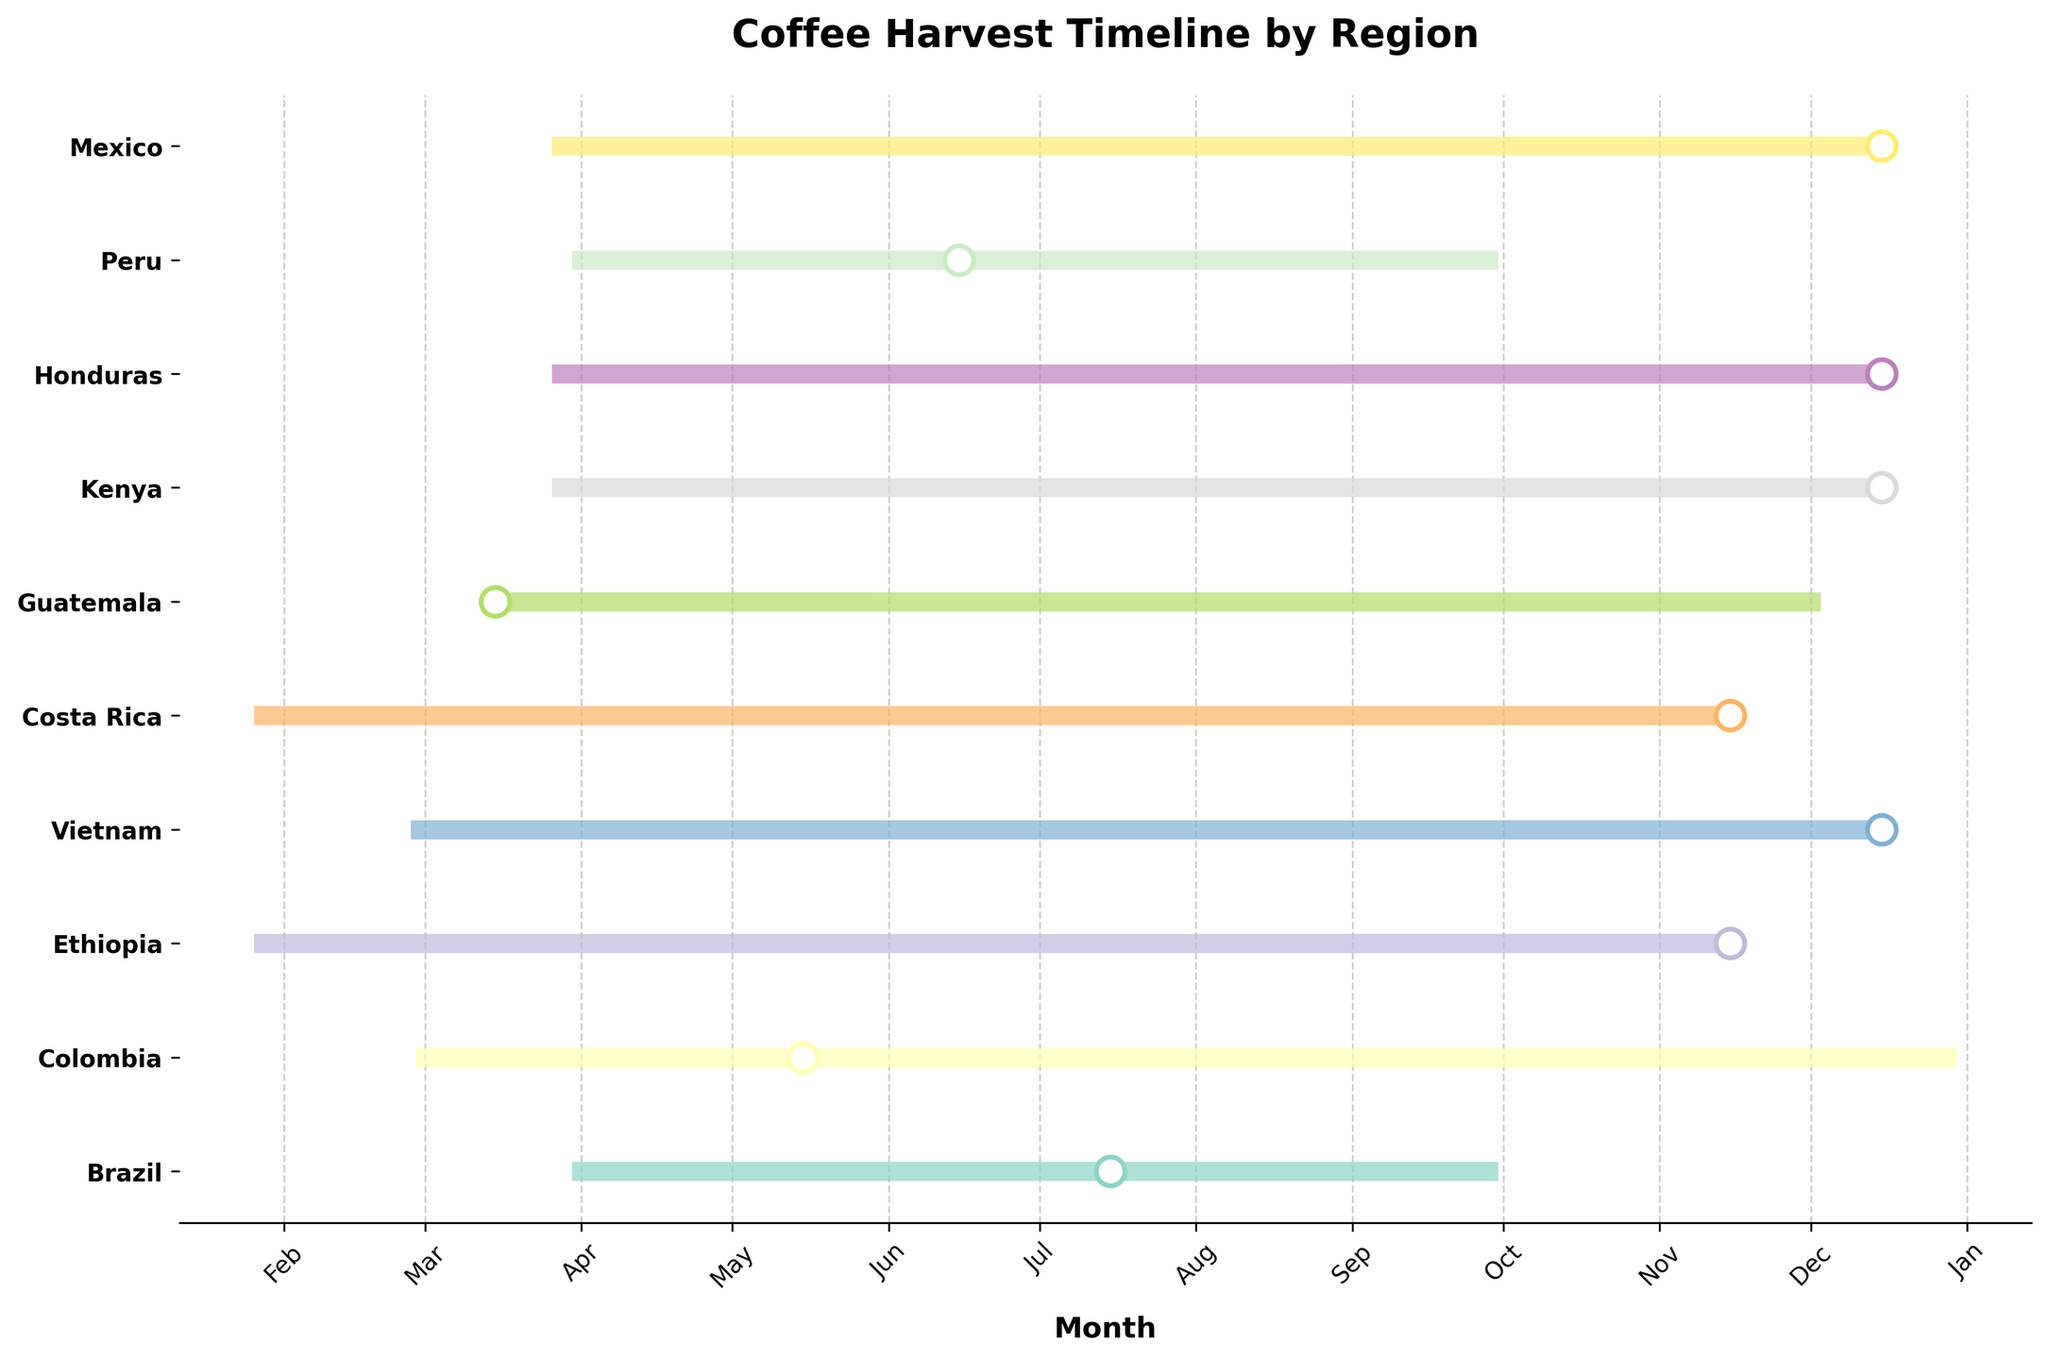What's the title of the plot? The title of the plot is typically positioned at the top of the figure, indicating the main subject or focus of the visualization.
Answer: Coffee Harvest Timeline by Region Which region has the earliest harvest start? To find the region with the earliest harvest start, look at the beginning points of each line on the timeline. The earliest harvest start date on the x-axis corresponds to March in Colombia.
Answer: Colombia During which months does Brazil's coffee harvest occur? Identify the range of the line corresponding to Brazil on the timeline. The line spans from April to September, which includes April, May, June, July, August, and September.
Answer: April to September Which regions have overlapping harvest peaks in December? Identify the regions with peak markers (the white circle) located in December. These regions include Vietnam, Kenya, Honduras, and Mexico.
Answer: Vietnam, Kenya, Honduras, Mexico What is the latest month any region has a harvest end? Look for the farthest right points of the lines on the timeline. The latest month a harvest ends is March in Colombia, Kenya, Honduras, and Mexico.
Answer: March How many regions have their harvest end in January? Count the number of lines that end in January. These regions include Ethiopia and Costa Rica, totaling two regions.
Answer: Two Which region has the longest harvest period? Calculate the duration from the harvest start to the harvest end for each region. Colombia's harvest period spans from March to December, which is 9 months, the longest among the regions.
Answer: Colombia Compare the harvest start times of Ethiopia and Costa Rica. Which starts earlier? Identify the starting point of the lines for Ethiopia and Costa Rica. Ethiopia starts in September, and Costa Rica starts in August. Therefore, Costa Rica starts earlier.
Answer: Costa Rica Which region has a harvest peak in November? Locate the regions with a peak marker (the white circle) in November. Both Ethiopia and Costa Rica have their peaks in November.
Answer: Ethiopia and Costa Rica How does the harvest duration of Peru compare to that of Guatemala? Calculate the duration from the harvest start to end for both regions. Peru's harvest duration is from April to September (6 months). Guatemala's harvest duration is from December to May (5 months). Therefore, Peru's harvest duration is longer.
Answer: Peru 